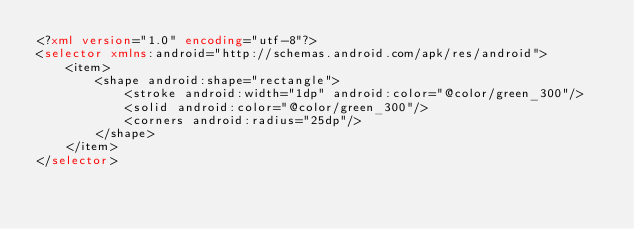Convert code to text. <code><loc_0><loc_0><loc_500><loc_500><_XML_><?xml version="1.0" encoding="utf-8"?>
<selector xmlns:android="http://schemas.android.com/apk/res/android">
    <item>
        <shape android:shape="rectangle">
            <stroke android:width="1dp" android:color="@color/green_300"/>
            <solid android:color="@color/green_300"/>
            <corners android:radius="25dp"/>
        </shape>
    </item>
</selector></code> 